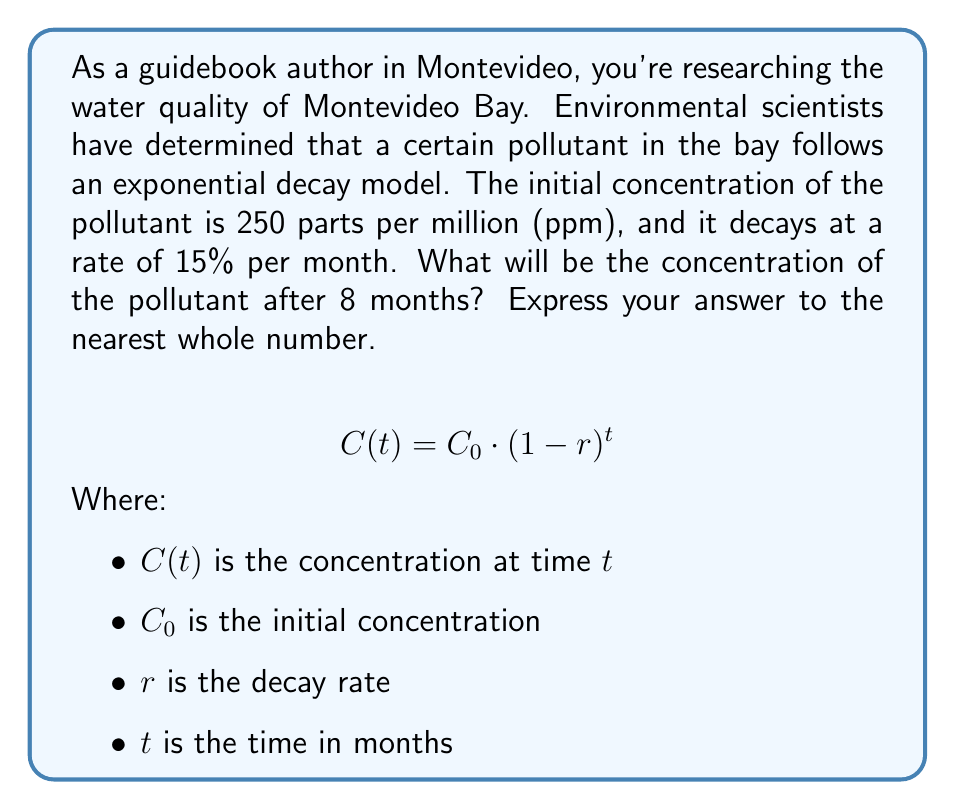Solve this math problem. To solve this problem, we'll use the exponential decay formula:

$$C(t) = C_0 \cdot (1-r)^t$$

Given:
- Initial concentration ($C_0$) = 250 ppm
- Decay rate ($r$) = 15% = 0.15
- Time ($t$) = 8 months

Let's substitute these values into the formula:

$$C(8) = 250 \cdot (1-0.15)^8$$

Simplify the expression inside the parentheses:

$$C(8) = 250 \cdot (0.85)^8$$

Now, we need to calculate $(0.85)^8$:

$$(0.85)^8 \approx 0.2725$$

Multiply this by the initial concentration:

$$C(8) = 250 \cdot 0.2725 \approx 68.125 \text{ ppm}$$

Rounding to the nearest whole number:

$$C(8) \approx 68 \text{ ppm}$$
Answer: 68 ppm 